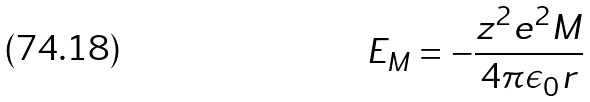Convert formula to latex. <formula><loc_0><loc_0><loc_500><loc_500>E _ { M } = - \frac { z ^ { 2 } e ^ { 2 } M } { 4 \pi \epsilon _ { 0 } r }</formula> 